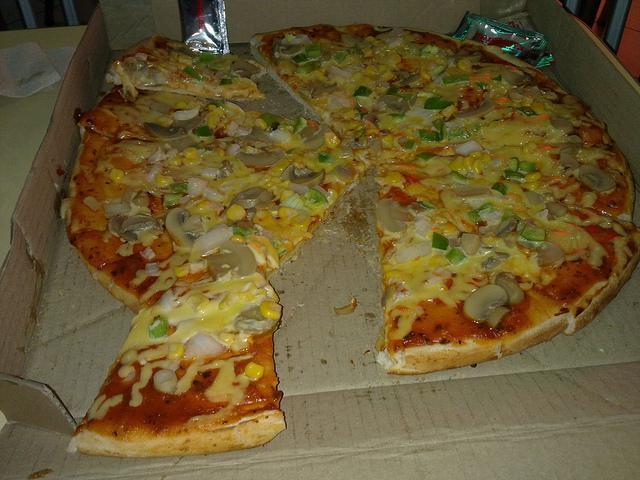How many slices of pizza are there?
Give a very brief answer. 12. How many slices of pizza is there?
Give a very brief answer. 12. How many types of pizza are there?
Give a very brief answer. 1. How many slices is the pizza cut into?
Give a very brief answer. 12. How many pizzas are on the table?
Give a very brief answer. 1. How many pizzas are there?
Give a very brief answer. 5. How many pieces is the cake cut into?
Give a very brief answer. 0. 